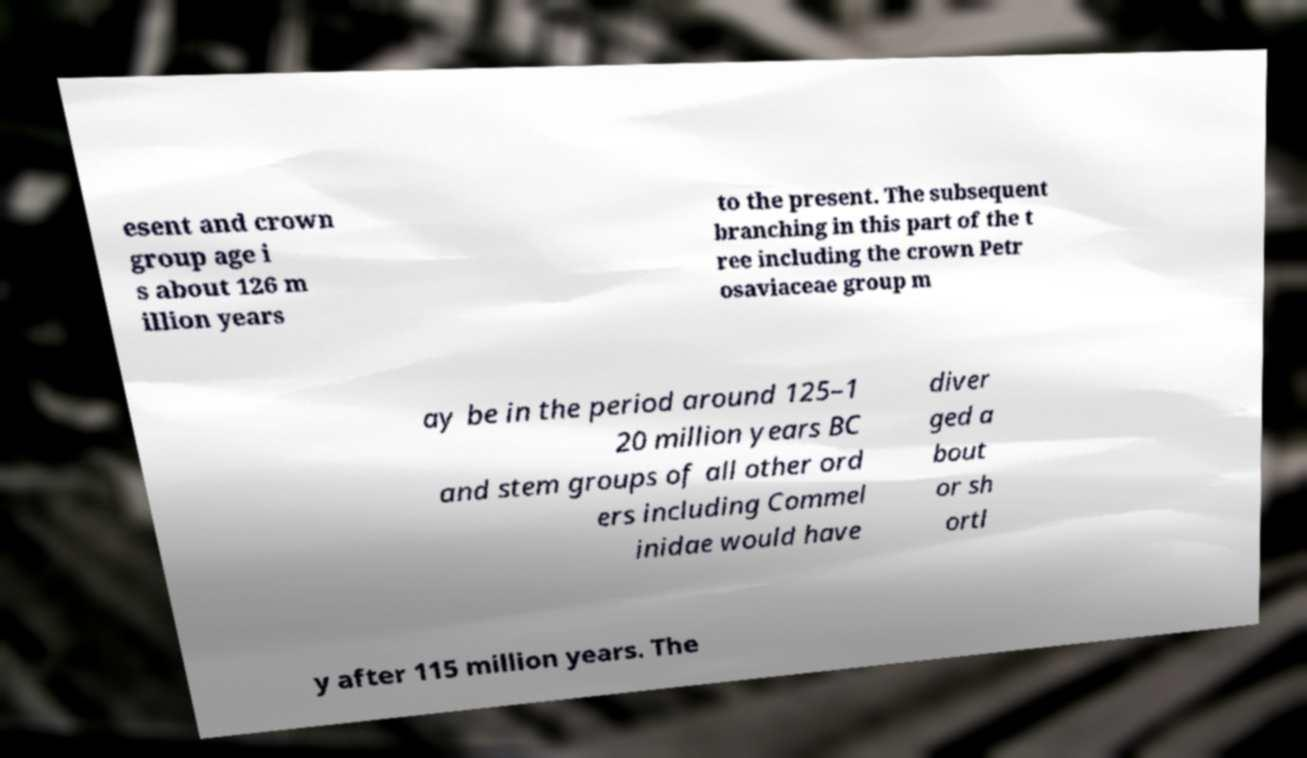What messages or text are displayed in this image? I need them in a readable, typed format. esent and crown group age i s about 126 m illion years to the present. The subsequent branching in this part of the t ree including the crown Petr osaviaceae group m ay be in the period around 125–1 20 million years BC and stem groups of all other ord ers including Commel inidae would have diver ged a bout or sh ortl y after 115 million years. The 